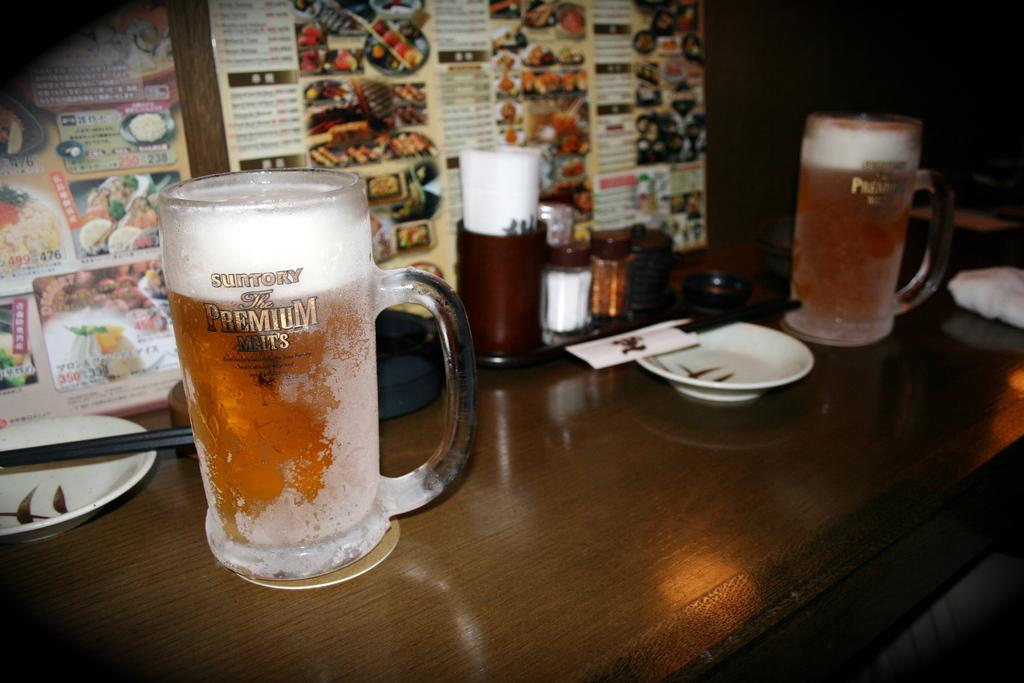What's the word on the glass starting with p?
Ensure brevity in your answer.  Premium. What is the brand of this beer?
Make the answer very short. Suntory. 